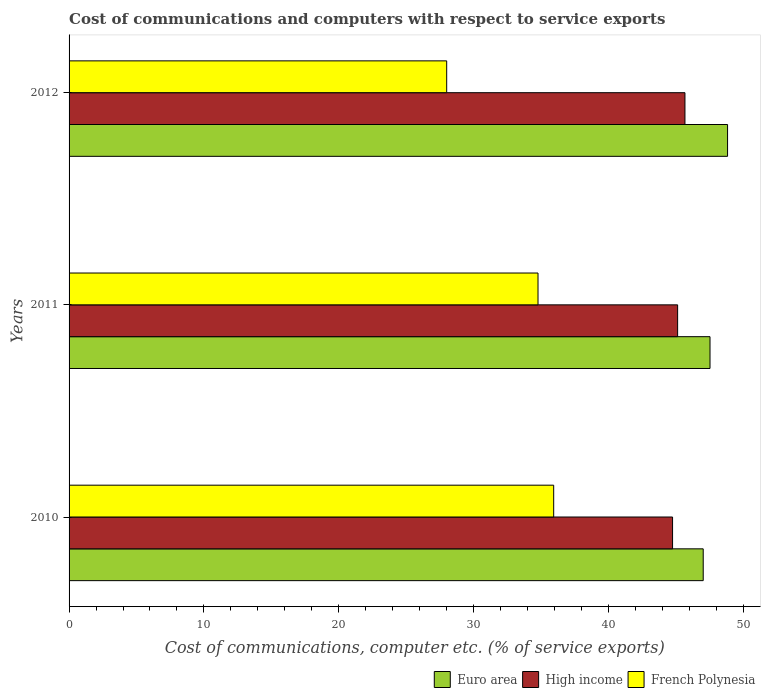How many different coloured bars are there?
Make the answer very short. 3. How many bars are there on the 2nd tick from the top?
Offer a terse response. 3. In how many cases, is the number of bars for a given year not equal to the number of legend labels?
Provide a short and direct response. 0. What is the cost of communications and computers in High income in 2012?
Provide a short and direct response. 45.68. Across all years, what is the maximum cost of communications and computers in Euro area?
Keep it short and to the point. 48.84. Across all years, what is the minimum cost of communications and computers in High income?
Keep it short and to the point. 44.76. In which year was the cost of communications and computers in High income maximum?
Your answer should be very brief. 2012. What is the total cost of communications and computers in High income in the graph?
Offer a very short reply. 135.58. What is the difference between the cost of communications and computers in Euro area in 2010 and that in 2012?
Your answer should be compact. -1.81. What is the difference between the cost of communications and computers in Euro area in 2010 and the cost of communications and computers in French Polynesia in 2011?
Provide a short and direct response. 12.25. What is the average cost of communications and computers in French Polynesia per year?
Your answer should be compact. 32.91. In the year 2011, what is the difference between the cost of communications and computers in French Polynesia and cost of communications and computers in High income?
Offer a terse response. -10.36. What is the ratio of the cost of communications and computers in Euro area in 2010 to that in 2011?
Give a very brief answer. 0.99. What is the difference between the highest and the second highest cost of communications and computers in Euro area?
Your answer should be very brief. 1.3. What is the difference between the highest and the lowest cost of communications and computers in French Polynesia?
Provide a short and direct response. 7.94. In how many years, is the cost of communications and computers in High income greater than the average cost of communications and computers in High income taken over all years?
Keep it short and to the point. 1. Is the sum of the cost of communications and computers in French Polynesia in 2010 and 2012 greater than the maximum cost of communications and computers in Euro area across all years?
Make the answer very short. Yes. What does the 1st bar from the top in 2011 represents?
Give a very brief answer. French Polynesia. Is it the case that in every year, the sum of the cost of communications and computers in Euro area and cost of communications and computers in French Polynesia is greater than the cost of communications and computers in High income?
Your answer should be very brief. Yes. How many bars are there?
Your response must be concise. 9. Are all the bars in the graph horizontal?
Offer a terse response. Yes. Are the values on the major ticks of X-axis written in scientific E-notation?
Offer a very short reply. No. What is the title of the graph?
Provide a short and direct response. Cost of communications and computers with respect to service exports. Does "French Polynesia" appear as one of the legend labels in the graph?
Your answer should be very brief. Yes. What is the label or title of the X-axis?
Offer a very short reply. Cost of communications, computer etc. (% of service exports). What is the Cost of communications, computer etc. (% of service exports) in Euro area in 2010?
Make the answer very short. 47.04. What is the Cost of communications, computer etc. (% of service exports) in High income in 2010?
Your answer should be compact. 44.76. What is the Cost of communications, computer etc. (% of service exports) of French Polynesia in 2010?
Offer a terse response. 35.95. What is the Cost of communications, computer etc. (% of service exports) in Euro area in 2011?
Ensure brevity in your answer.  47.54. What is the Cost of communications, computer etc. (% of service exports) in High income in 2011?
Offer a terse response. 45.14. What is the Cost of communications, computer etc. (% of service exports) in French Polynesia in 2011?
Offer a very short reply. 34.78. What is the Cost of communications, computer etc. (% of service exports) in Euro area in 2012?
Offer a very short reply. 48.84. What is the Cost of communications, computer etc. (% of service exports) of High income in 2012?
Give a very brief answer. 45.68. What is the Cost of communications, computer etc. (% of service exports) of French Polynesia in 2012?
Make the answer very short. 28.01. Across all years, what is the maximum Cost of communications, computer etc. (% of service exports) of Euro area?
Provide a succinct answer. 48.84. Across all years, what is the maximum Cost of communications, computer etc. (% of service exports) of High income?
Make the answer very short. 45.68. Across all years, what is the maximum Cost of communications, computer etc. (% of service exports) of French Polynesia?
Give a very brief answer. 35.95. Across all years, what is the minimum Cost of communications, computer etc. (% of service exports) of Euro area?
Your answer should be compact. 47.04. Across all years, what is the minimum Cost of communications, computer etc. (% of service exports) in High income?
Ensure brevity in your answer.  44.76. Across all years, what is the minimum Cost of communications, computer etc. (% of service exports) in French Polynesia?
Your answer should be very brief. 28.01. What is the total Cost of communications, computer etc. (% of service exports) of Euro area in the graph?
Provide a succinct answer. 143.42. What is the total Cost of communications, computer etc. (% of service exports) in High income in the graph?
Offer a terse response. 135.58. What is the total Cost of communications, computer etc. (% of service exports) in French Polynesia in the graph?
Ensure brevity in your answer.  98.74. What is the difference between the Cost of communications, computer etc. (% of service exports) of Euro area in 2010 and that in 2011?
Your response must be concise. -0.5. What is the difference between the Cost of communications, computer etc. (% of service exports) of High income in 2010 and that in 2011?
Keep it short and to the point. -0.38. What is the difference between the Cost of communications, computer etc. (% of service exports) of French Polynesia in 2010 and that in 2011?
Give a very brief answer. 1.16. What is the difference between the Cost of communications, computer etc. (% of service exports) in Euro area in 2010 and that in 2012?
Offer a terse response. -1.81. What is the difference between the Cost of communications, computer etc. (% of service exports) in High income in 2010 and that in 2012?
Provide a succinct answer. -0.92. What is the difference between the Cost of communications, computer etc. (% of service exports) in French Polynesia in 2010 and that in 2012?
Provide a short and direct response. 7.94. What is the difference between the Cost of communications, computer etc. (% of service exports) in Euro area in 2011 and that in 2012?
Give a very brief answer. -1.3. What is the difference between the Cost of communications, computer etc. (% of service exports) of High income in 2011 and that in 2012?
Give a very brief answer. -0.54. What is the difference between the Cost of communications, computer etc. (% of service exports) in French Polynesia in 2011 and that in 2012?
Your answer should be compact. 6.77. What is the difference between the Cost of communications, computer etc. (% of service exports) in Euro area in 2010 and the Cost of communications, computer etc. (% of service exports) in High income in 2011?
Keep it short and to the point. 1.9. What is the difference between the Cost of communications, computer etc. (% of service exports) in Euro area in 2010 and the Cost of communications, computer etc. (% of service exports) in French Polynesia in 2011?
Offer a terse response. 12.25. What is the difference between the Cost of communications, computer etc. (% of service exports) of High income in 2010 and the Cost of communications, computer etc. (% of service exports) of French Polynesia in 2011?
Provide a short and direct response. 9.98. What is the difference between the Cost of communications, computer etc. (% of service exports) in Euro area in 2010 and the Cost of communications, computer etc. (% of service exports) in High income in 2012?
Offer a very short reply. 1.35. What is the difference between the Cost of communications, computer etc. (% of service exports) in Euro area in 2010 and the Cost of communications, computer etc. (% of service exports) in French Polynesia in 2012?
Ensure brevity in your answer.  19.03. What is the difference between the Cost of communications, computer etc. (% of service exports) in High income in 2010 and the Cost of communications, computer etc. (% of service exports) in French Polynesia in 2012?
Your response must be concise. 16.75. What is the difference between the Cost of communications, computer etc. (% of service exports) of Euro area in 2011 and the Cost of communications, computer etc. (% of service exports) of High income in 2012?
Your answer should be very brief. 1.86. What is the difference between the Cost of communications, computer etc. (% of service exports) of Euro area in 2011 and the Cost of communications, computer etc. (% of service exports) of French Polynesia in 2012?
Your response must be concise. 19.53. What is the difference between the Cost of communications, computer etc. (% of service exports) in High income in 2011 and the Cost of communications, computer etc. (% of service exports) in French Polynesia in 2012?
Provide a short and direct response. 17.13. What is the average Cost of communications, computer etc. (% of service exports) in Euro area per year?
Make the answer very short. 47.81. What is the average Cost of communications, computer etc. (% of service exports) in High income per year?
Ensure brevity in your answer.  45.19. What is the average Cost of communications, computer etc. (% of service exports) in French Polynesia per year?
Give a very brief answer. 32.91. In the year 2010, what is the difference between the Cost of communications, computer etc. (% of service exports) of Euro area and Cost of communications, computer etc. (% of service exports) of High income?
Keep it short and to the point. 2.27. In the year 2010, what is the difference between the Cost of communications, computer etc. (% of service exports) of Euro area and Cost of communications, computer etc. (% of service exports) of French Polynesia?
Provide a short and direct response. 11.09. In the year 2010, what is the difference between the Cost of communications, computer etc. (% of service exports) in High income and Cost of communications, computer etc. (% of service exports) in French Polynesia?
Make the answer very short. 8.82. In the year 2011, what is the difference between the Cost of communications, computer etc. (% of service exports) in Euro area and Cost of communications, computer etc. (% of service exports) in High income?
Offer a very short reply. 2.4. In the year 2011, what is the difference between the Cost of communications, computer etc. (% of service exports) of Euro area and Cost of communications, computer etc. (% of service exports) of French Polynesia?
Your answer should be very brief. 12.76. In the year 2011, what is the difference between the Cost of communications, computer etc. (% of service exports) of High income and Cost of communications, computer etc. (% of service exports) of French Polynesia?
Your answer should be compact. 10.36. In the year 2012, what is the difference between the Cost of communications, computer etc. (% of service exports) in Euro area and Cost of communications, computer etc. (% of service exports) in High income?
Make the answer very short. 3.16. In the year 2012, what is the difference between the Cost of communications, computer etc. (% of service exports) in Euro area and Cost of communications, computer etc. (% of service exports) in French Polynesia?
Your response must be concise. 20.83. In the year 2012, what is the difference between the Cost of communications, computer etc. (% of service exports) of High income and Cost of communications, computer etc. (% of service exports) of French Polynesia?
Offer a terse response. 17.67. What is the ratio of the Cost of communications, computer etc. (% of service exports) in French Polynesia in 2010 to that in 2011?
Your response must be concise. 1.03. What is the ratio of the Cost of communications, computer etc. (% of service exports) in High income in 2010 to that in 2012?
Make the answer very short. 0.98. What is the ratio of the Cost of communications, computer etc. (% of service exports) of French Polynesia in 2010 to that in 2012?
Your answer should be very brief. 1.28. What is the ratio of the Cost of communications, computer etc. (% of service exports) of Euro area in 2011 to that in 2012?
Give a very brief answer. 0.97. What is the ratio of the Cost of communications, computer etc. (% of service exports) in French Polynesia in 2011 to that in 2012?
Your response must be concise. 1.24. What is the difference between the highest and the second highest Cost of communications, computer etc. (% of service exports) in Euro area?
Keep it short and to the point. 1.3. What is the difference between the highest and the second highest Cost of communications, computer etc. (% of service exports) of High income?
Make the answer very short. 0.54. What is the difference between the highest and the second highest Cost of communications, computer etc. (% of service exports) in French Polynesia?
Keep it short and to the point. 1.16. What is the difference between the highest and the lowest Cost of communications, computer etc. (% of service exports) in Euro area?
Provide a succinct answer. 1.81. What is the difference between the highest and the lowest Cost of communications, computer etc. (% of service exports) in High income?
Your response must be concise. 0.92. What is the difference between the highest and the lowest Cost of communications, computer etc. (% of service exports) of French Polynesia?
Keep it short and to the point. 7.94. 